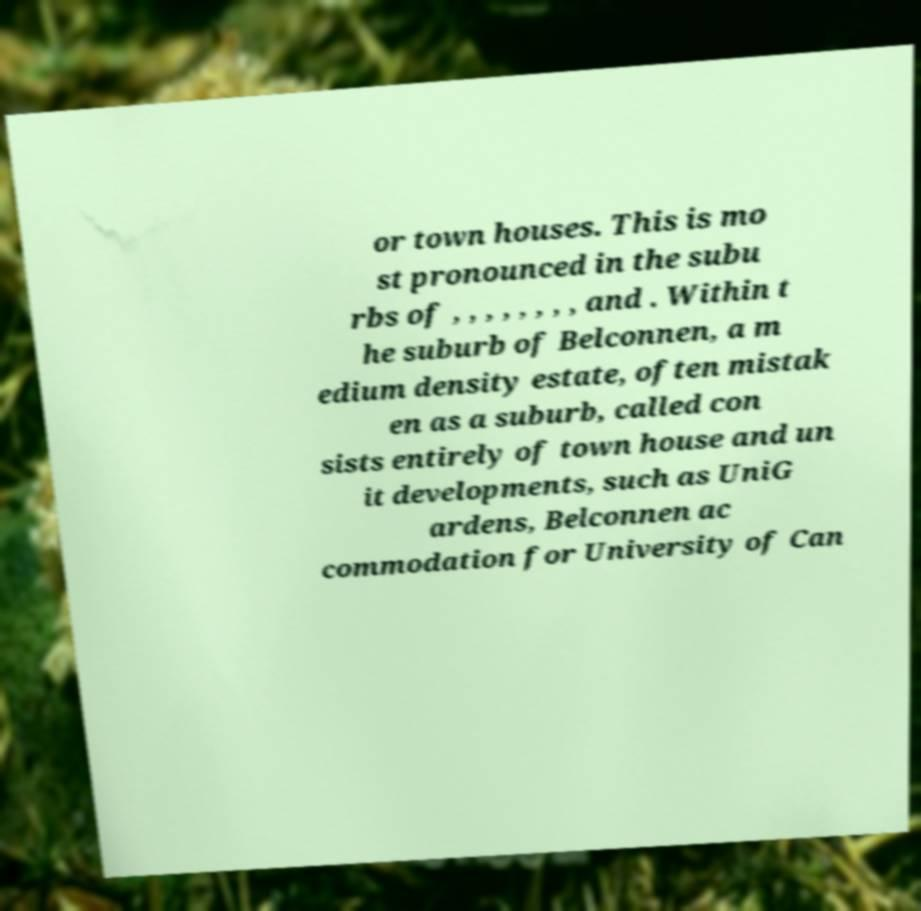Could you assist in decoding the text presented in this image and type it out clearly? or town houses. This is mo st pronounced in the subu rbs of , , , , , , , , and . Within t he suburb of Belconnen, a m edium density estate, often mistak en as a suburb, called con sists entirely of town house and un it developments, such as UniG ardens, Belconnen ac commodation for University of Can 